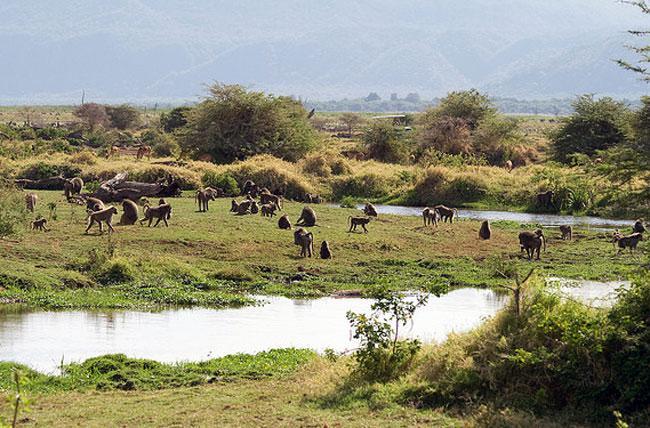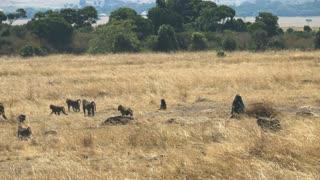The first image is the image on the left, the second image is the image on the right. Evaluate the accuracy of this statement regarding the images: "Right image includes no more than five baboons.". Is it true? Answer yes or no. No. The first image is the image on the left, the second image is the image on the right. Analyze the images presented: Is the assertion "At least one image shows monkeys that are walking in one direction." valid? Answer yes or no. No. The first image is the image on the left, the second image is the image on the right. Analyze the images presented: Is the assertion "Some of the animals are on or near a dirt path." valid? Answer yes or no. No. 